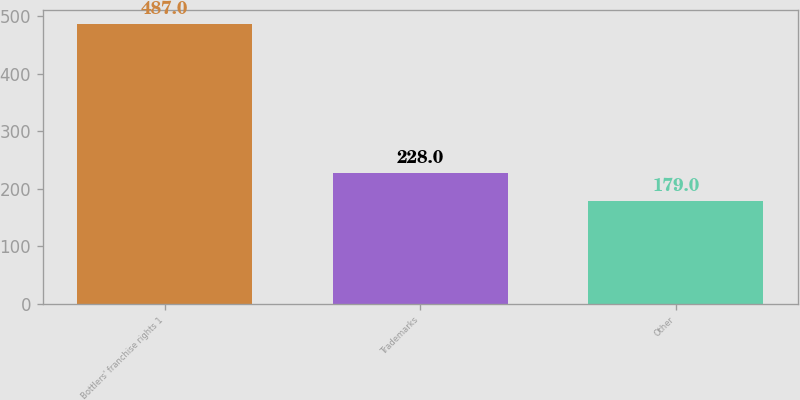<chart> <loc_0><loc_0><loc_500><loc_500><bar_chart><fcel>Bottlers' franchise rights 1<fcel>Trademarks<fcel>Other<nl><fcel>487<fcel>228<fcel>179<nl></chart> 